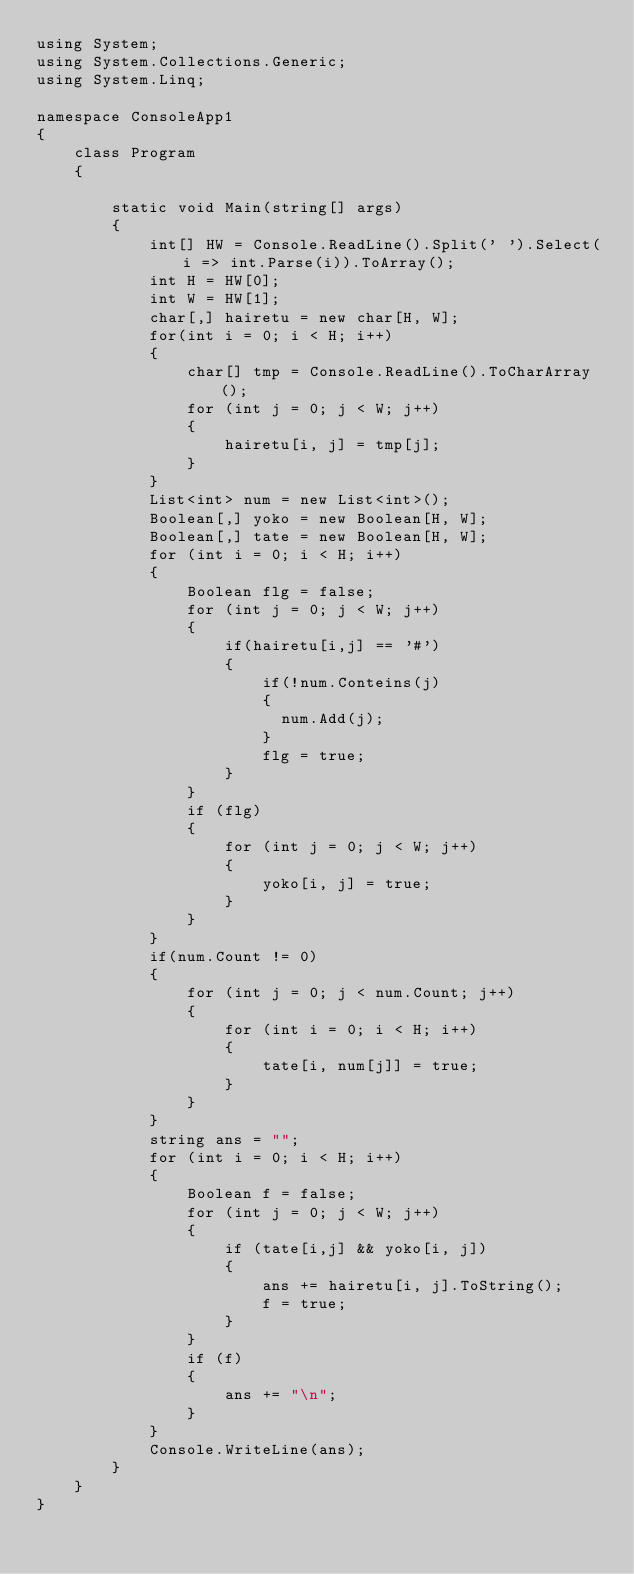<code> <loc_0><loc_0><loc_500><loc_500><_C#_>using System;
using System.Collections.Generic;
using System.Linq;

namespace ConsoleApp1
{
    class Program
    {
  
        static void Main(string[] args)
        {
            int[] HW = Console.ReadLine().Split(' ').Select(i => int.Parse(i)).ToArray();
            int H = HW[0];
            int W = HW[1];
            char[,] hairetu = new char[H, W];
            for(int i = 0; i < H; i++)
            {
                char[] tmp = Console.ReadLine().ToCharArray();
                for (int j = 0; j < W; j++)
                {
                    hairetu[i, j] = tmp[j];
                }
            }
            List<int> num = new List<int>();
            Boolean[,] yoko = new Boolean[H, W];
            Boolean[,] tate = new Boolean[H, W];
            for (int i = 0; i < H; i++)
            {
                Boolean flg = false;
                for (int j = 0; j < W; j++)
                {
                    if(hairetu[i,j] == '#')
                    {
                        if(!num.Conteins(j)
                        {
                        	num.Add(j);
                        }
                        flg = true;
                    }
                }
                if (flg)
                {
                    for (int j = 0; j < W; j++)
                    {
                        yoko[i, j] = true;
                    }
                }
            }
            if(num.Count != 0)
            {
                for (int j = 0; j < num.Count; j++)
                {
                    for (int i = 0; i < H; i++)
                    {
                        tate[i, num[j]] = true;
                    }
                }
            }
            string ans = "";
            for (int i = 0; i < H; i++)
            {
                Boolean f = false;
                for (int j = 0; j < W; j++)
                {
                    if (tate[i,j] && yoko[i, j])
                    {
                        ans += hairetu[i, j].ToString();
                        f = true;
                    }
                }
                if (f)
                {
                    ans += "\n";
                }
            }
            Console.WriteLine(ans);
        }
    }
}</code> 